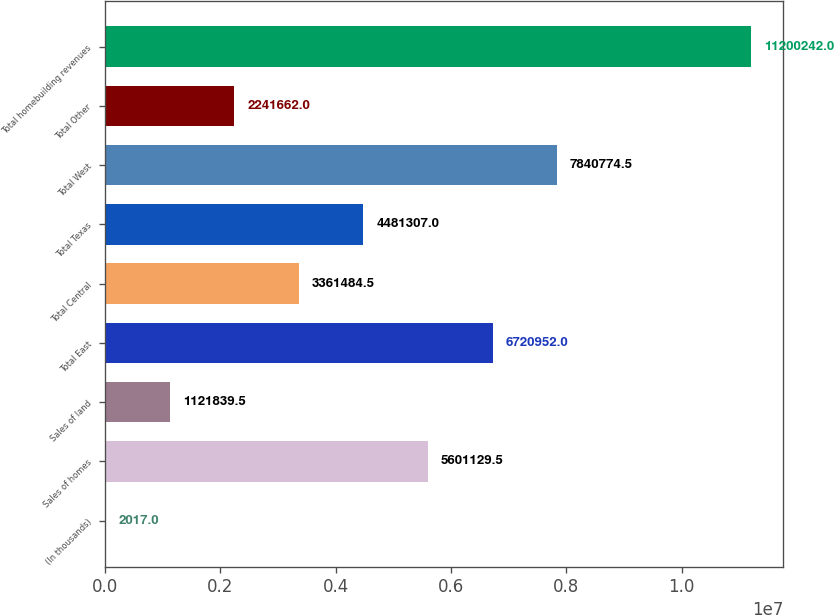<chart> <loc_0><loc_0><loc_500><loc_500><bar_chart><fcel>(In thousands)<fcel>Sales of homes<fcel>Sales of land<fcel>Total East<fcel>Total Central<fcel>Total Texas<fcel>Total West<fcel>Total Other<fcel>Total homebuilding revenues<nl><fcel>2017<fcel>5.60113e+06<fcel>1.12184e+06<fcel>6.72095e+06<fcel>3.36148e+06<fcel>4.48131e+06<fcel>7.84077e+06<fcel>2.24166e+06<fcel>1.12002e+07<nl></chart> 